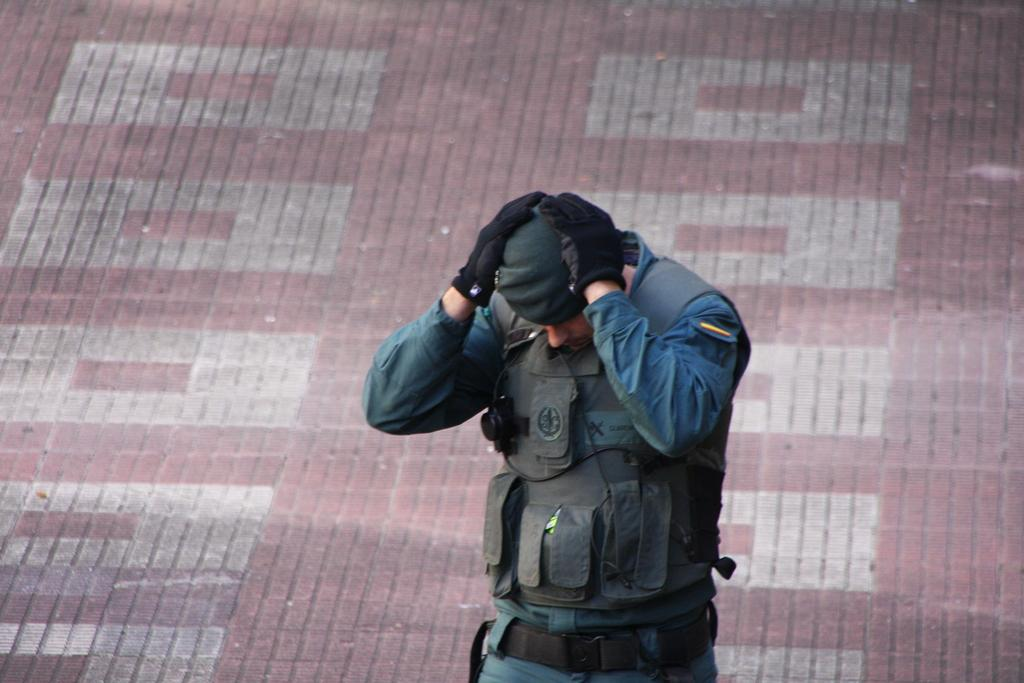Who is the main subject in the image? There is a man in the image. Where is the man positioned in the image? The man is standing in the center of the image. What is the man doing with his hands in the image? The man has his hands on his head. What type of space attraction can be seen in the image? There is no space attraction present in the image; it features a man standing with his hands on his head. What is the aftermath of the event depicted in the image? There is no event or aftermath depicted in the image; it simply shows a man standing with his hands on his head. 